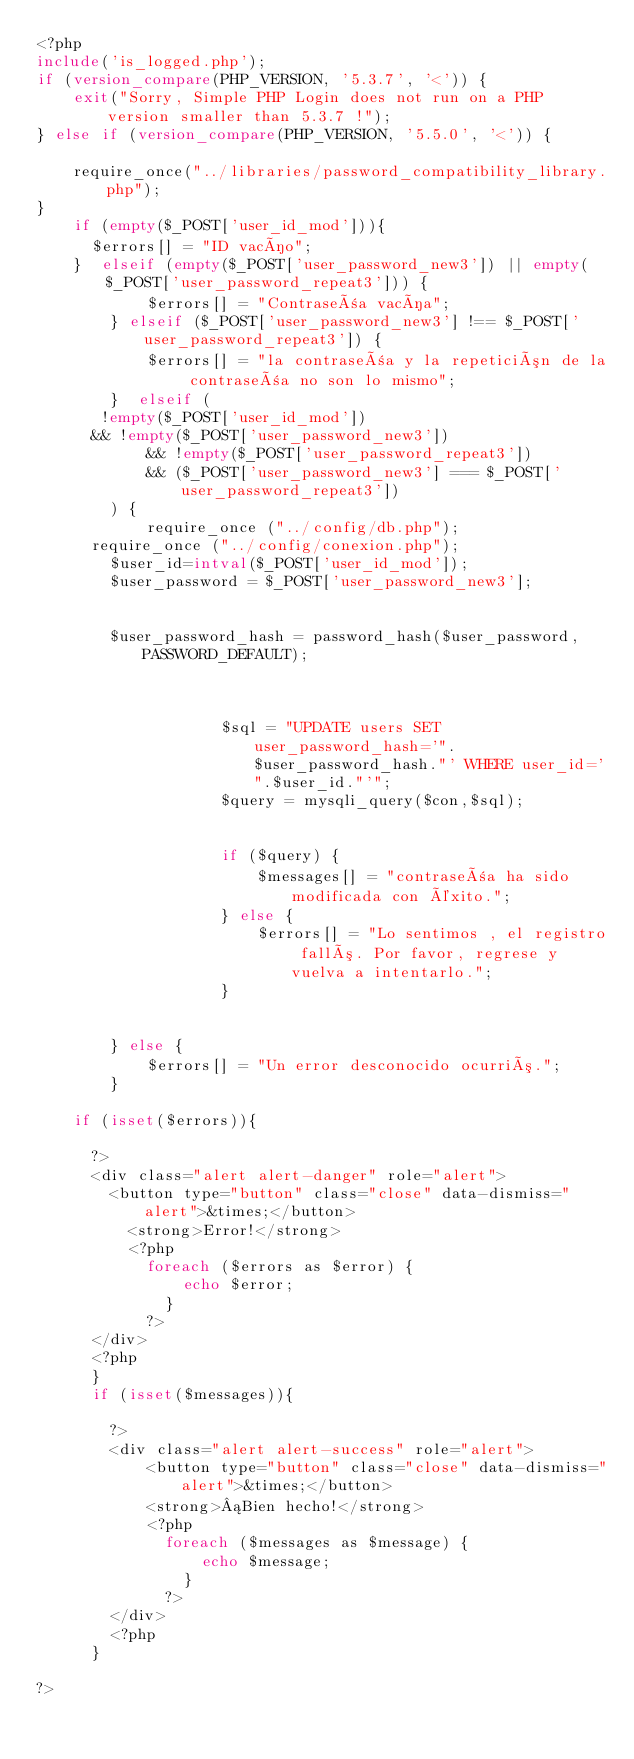Convert code to text. <code><loc_0><loc_0><loc_500><loc_500><_PHP_><?php
include('is_logged.php');
if (version_compare(PHP_VERSION, '5.3.7', '<')) {
    exit("Sorry, Simple PHP Login does not run on a PHP version smaller than 5.3.7 !");
} else if (version_compare(PHP_VERSION, '5.5.0', '<')) {
   
    require_once("../libraries/password_compatibility_library.php");
}		
		if (empty($_POST['user_id_mod'])){
			$errors[] = "ID vacío";
		}  elseif (empty($_POST['user_password_new3']) || empty($_POST['user_password_repeat3'])) {
            $errors[] = "Contraseña vacía";
        } elseif ($_POST['user_password_new3'] !== $_POST['user_password_repeat3']) {
            $errors[] = "la contraseña y la repetición de la contraseña no son lo mismo";
        }  elseif (
			 !empty($_POST['user_id_mod'])
			&& !empty($_POST['user_password_new3'])
            && !empty($_POST['user_password_repeat3'])
            && ($_POST['user_password_new3'] === $_POST['user_password_repeat3'])
        ) {
            require_once ("../config/db.php");
			require_once ("../config/conexion.php");
				$user_id=intval($_POST['user_id_mod']);
				$user_password = $_POST['user_password_new3'];
				
           
				$user_password_hash = password_hash($user_password, PASSWORD_DEFAULT);
					
               
				
                    $sql = "UPDATE users SET user_password_hash='".$user_password_hash."' WHERE user_id='".$user_id."'";
                    $query = mysqli_query($con,$sql);

                  
                    if ($query) {
                        $messages[] = "contraseña ha sido modificada con éxito.";
                    } else {
                        $errors[] = "Lo sentimos , el registro falló. Por favor, regrese y vuelva a intentarlo.";
                    }
                
            
        } else {
            $errors[] = "Un error desconocido ocurrió.";
        }
		
		if (isset($errors)){
			
			?>
			<div class="alert alert-danger" role="alert">
				<button type="button" class="close" data-dismiss="alert">&times;</button>
					<strong>Error!</strong> 
					<?php
						foreach ($errors as $error) {
								echo $error;
							}
						?>
			</div>
			<?php
			}
			if (isset($messages)){
				
				?>
				<div class="alert alert-success" role="alert">
						<button type="button" class="close" data-dismiss="alert">&times;</button>
						<strong>¡Bien hecho!</strong>
						<?php
							foreach ($messages as $message) {
									echo $message;
								}
							?>
				</div>
				<?php
			}

?></code> 